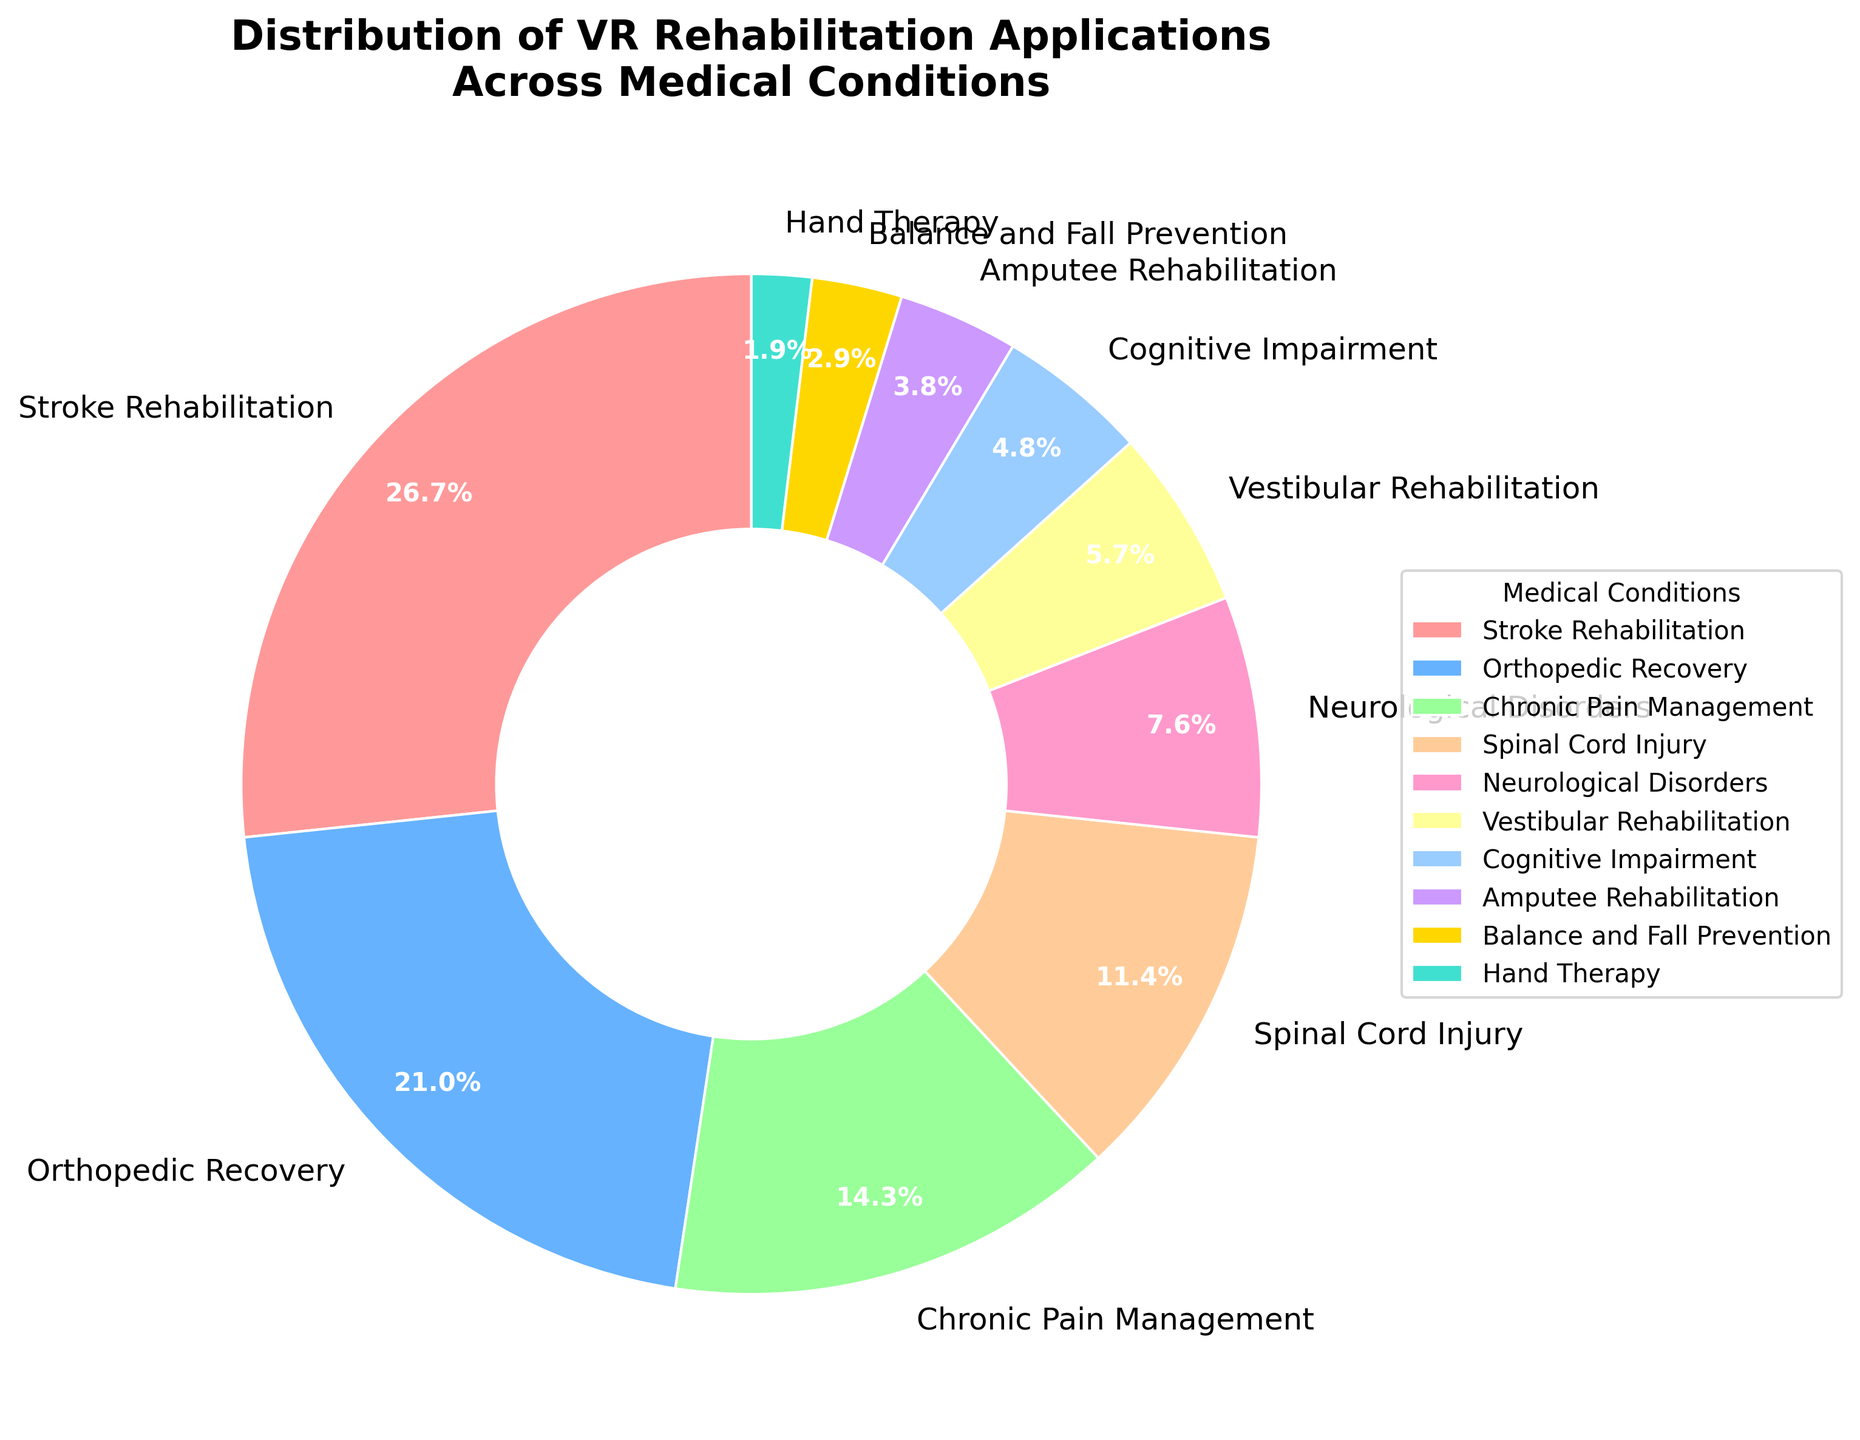What medical condition has the highest allocation percentage in VR rehabilitation applications? The slice for Stroke Rehabilitation is the largest in the pie chart. It takes up 28% of the total distribution, which is the highest percentage.
Answer: Stroke Rehabilitation What is the total percentage allocated to Orthopedic Recovery and Chronic Pain Management combined? The percentage for Orthopedic Recovery is 22% and for Chronic Pain Management is 15%. Adding them together gives 22% + 15%, which equals 37%.
Answer: 37% Which two medical conditions have the smallest representation in VR rehabilitation applications? The slices for Hand Therapy and Balance and Fall Prevention are the smallest. Hand Therapy is 2%, and Balance and Fall Prevention is 3%.
Answer: Hand Therapy and Balance and Fall Prevention How much more percentage is allocated to Stroke Rehabilitation compared to Cognitive Impairment? Stroke Rehabilitation has 28%, and Cognitive Impairment has 5%. The difference is 28% - 5%, which is 23%.
Answer: 23% Is the representation of Vestibular Rehabilitation larger than that of Cognitive Impairment? The slice for Vestibular Rehabilitation represents 6%, while the slice for Cognitive Impairment represents 5%. Since 6% is greater than 5%, Vestibular Rehabilitation has a larger representation.
Answer: Yes What is the combined percentage of all medical conditions related to neurological issues (Stroke Rehabilitation, Spinal Cord Injury, Neurological Disorders, Cognitive Impairment)? The percentages are Stroke Rehabilitation (28%), Spinal Cord Injury (12%), Neurological Disorders (8%), and Cognitive Impairment (5%). Summing these gives 28% + 12% + 8% + 5%, which equals 53%.
Answer: 53% If we combine the percentages of Spinal Cord Injury and Amputee Rehabilitation, is their total percentage greater than Orthopedic Recovery? Spinal Cord Injury is 12%, and Amputee Rehabilitation is 4%. Summing these gives 12% + 4%, which equals 16%, which is less than Orthopedic Recovery at 22%.
Answer: No What percentage is represented by medical conditions that have a percentage allocation less than 10%? The conditions with less than 10% are Neurological Disorders (8%), Vestibular Rehabilitation (6%), Cognitive Impairment (5%), Amputee Rehabilitation (4%), Balance and Fall Prevention (3%), and Hand Therapy (2%). Summing these gives 8% + 6% + 5% + 4% + 3% + 2%, which equals 28%.
Answer: 28% Compare the percentages of Orthopedic Recovery and Spinal Cord Injury. Which one has a higher percentage and by how much? Orthopedic Recovery has 22%, and Spinal Cord Injury has 12%. The difference is 22% - 12%, which is 10%. Orthopedic Recovery has the higher percentage.
Answer: Orthopedic Recovery by 10% 